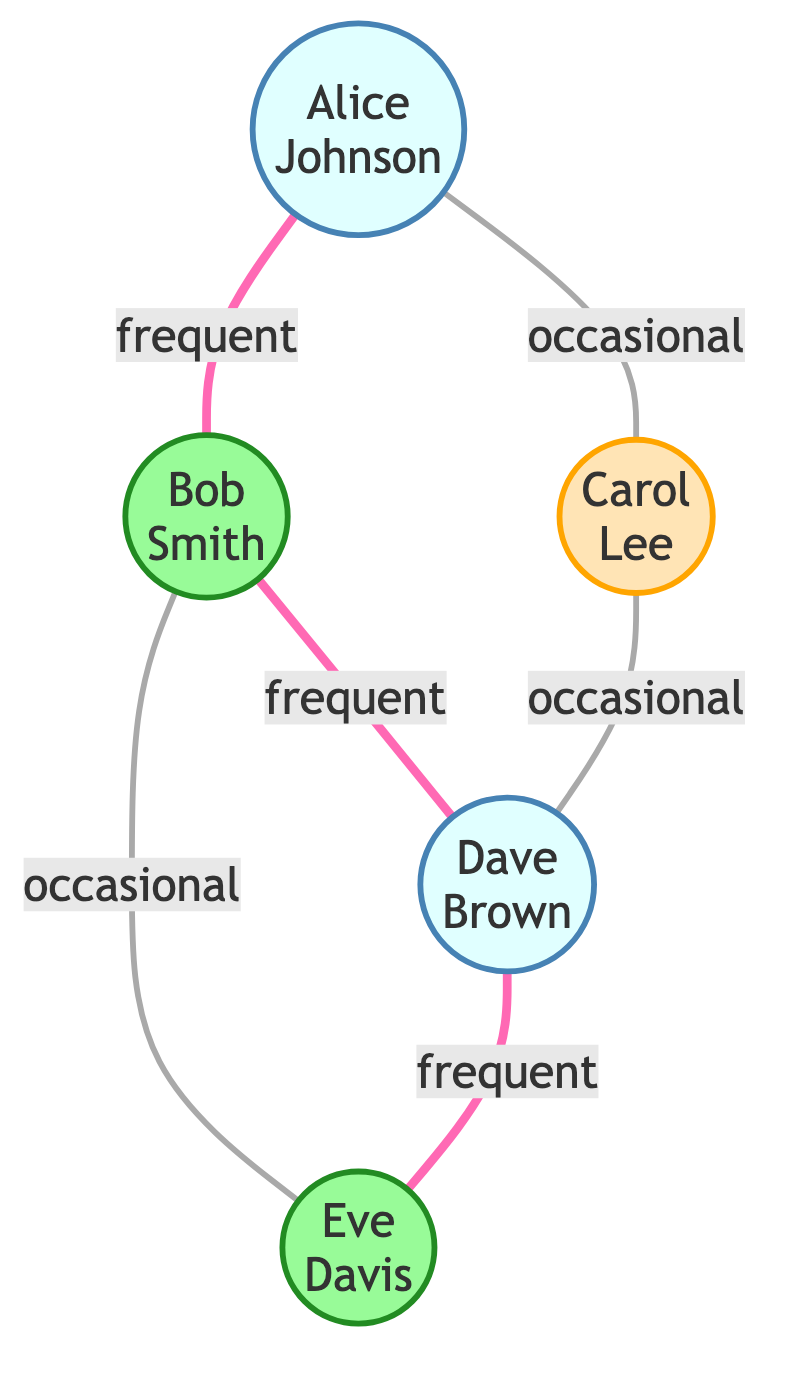What is the total number of players in the social network? There are 5 nodes in the diagram, each representing a player in the local disc golf community.
Answer: 5 Who has frequent interactions with Dave Brown? The edges in the diagram show that Bob Smith and Eve Davis both have a frequent interaction with Dave Brown.
Answer: Bob Smith, Eve Davis What is the skill level of Carol Lee? The data clearly indicates that Carol Lee's skill level is listed as beginner.
Answer: beginner How many total friendships (edges) are represented in the graph? Counting the edges, there are 6 connections representing friendships or interactions between the players.
Answer: 6 Who is the most connected player based on the frequency of interactions? By analyzing the interactions, Bob Smith has 3 edges connected (to Alice, Dave, and Eve), indicating he is the most connected player.
Answer: Bob Smith Which player has occasional interactions with both Alice Johnson and Dave Brown? The edges show that Carol Lee has an occasional interaction with Alice Johnson and also has a connection with Dave Brown, fulfilling the criteria.
Answer: Carol Lee How many players have a skill level of advanced? By inspecting the nodes, both Bob Smith and Eve Davis have an advanced skill level, resulting in a count of 2 players.
Answer: 2 Which two players frequently interact with each other? Looking at the graph, Alice Johnson frequently interacts with Bob Smith, and Dave Brown frequently interacts with Eve Davis.
Answer: Alice Johnson, Bob Smith / Dave Brown, Eve Davis Does any player have only occasional interactions? Analyzing the edges, it's clear that both Carol Lee and Eve Davis each have at least one occasional interaction.
Answer: Yes 